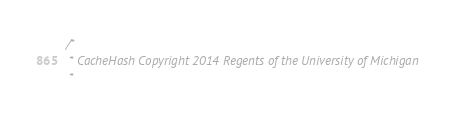Convert code to text. <code><loc_0><loc_0><loc_500><loc_500><_C_>/*
 * CacheHash Copyright 2014 Regents of the University of Michigan
 *</code> 